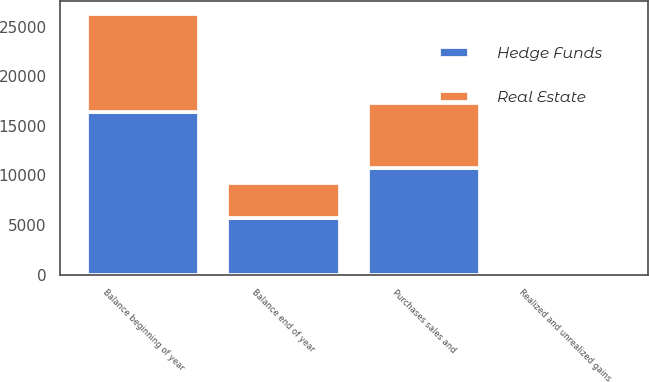<chart> <loc_0><loc_0><loc_500><loc_500><stacked_bar_chart><ecel><fcel>Balance beginning of year<fcel>Purchases sales and<fcel>Realized and unrealized gains<fcel>Balance end of year<nl><fcel>Real Estate<fcel>9914<fcel>6530<fcel>93<fcel>3477<nl><fcel>Hedge Funds<fcel>16372<fcel>10788<fcel>131<fcel>5715<nl></chart> 